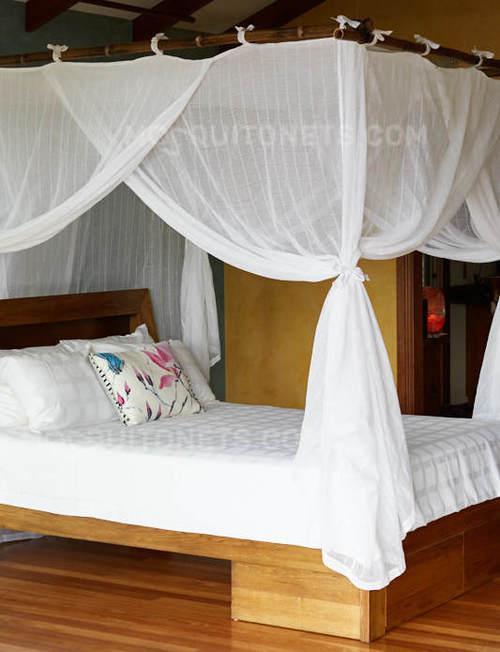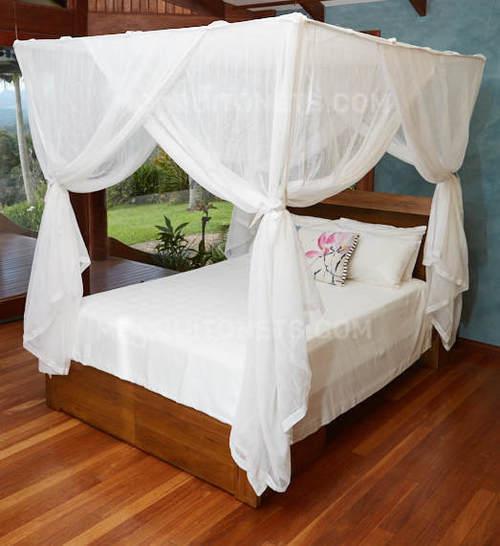The first image is the image on the left, the second image is the image on the right. Given the left and right images, does the statement "One image shows a canopy suspended from the ceiling that drapes the bed from a cone shape." hold true? Answer yes or no. No. 